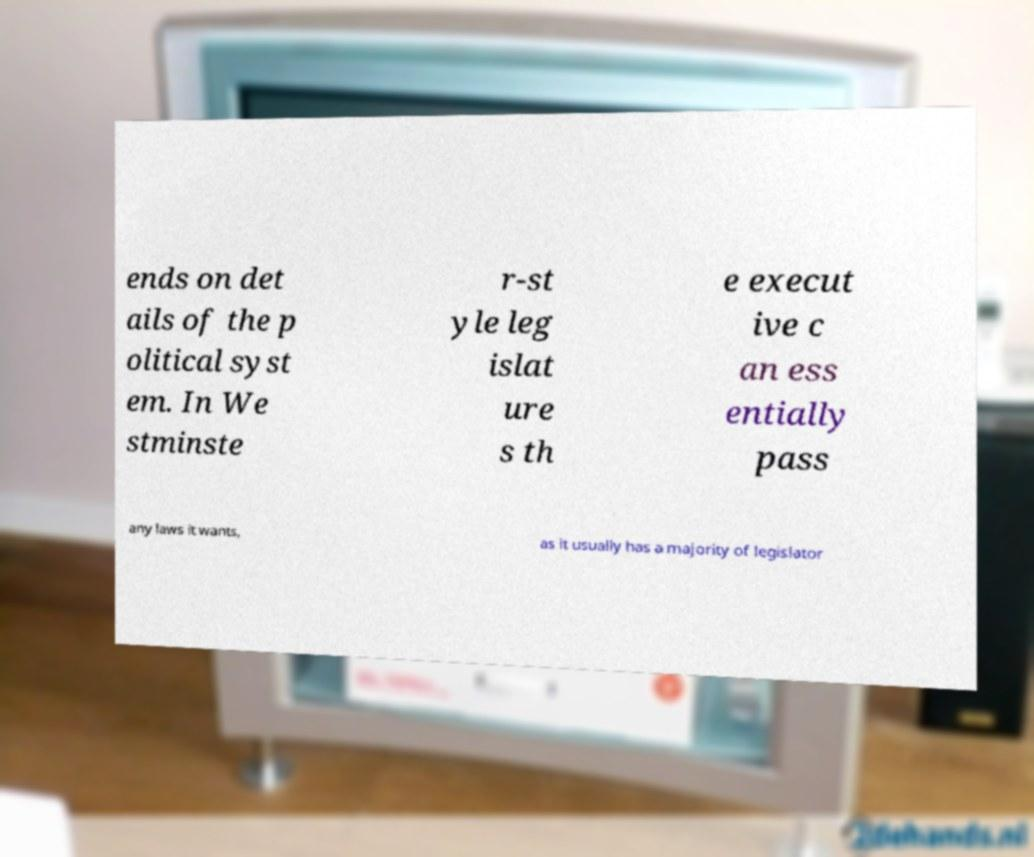Could you assist in decoding the text presented in this image and type it out clearly? ends on det ails of the p olitical syst em. In We stminste r-st yle leg islat ure s th e execut ive c an ess entially pass any laws it wants, as it usually has a majority of legislator 